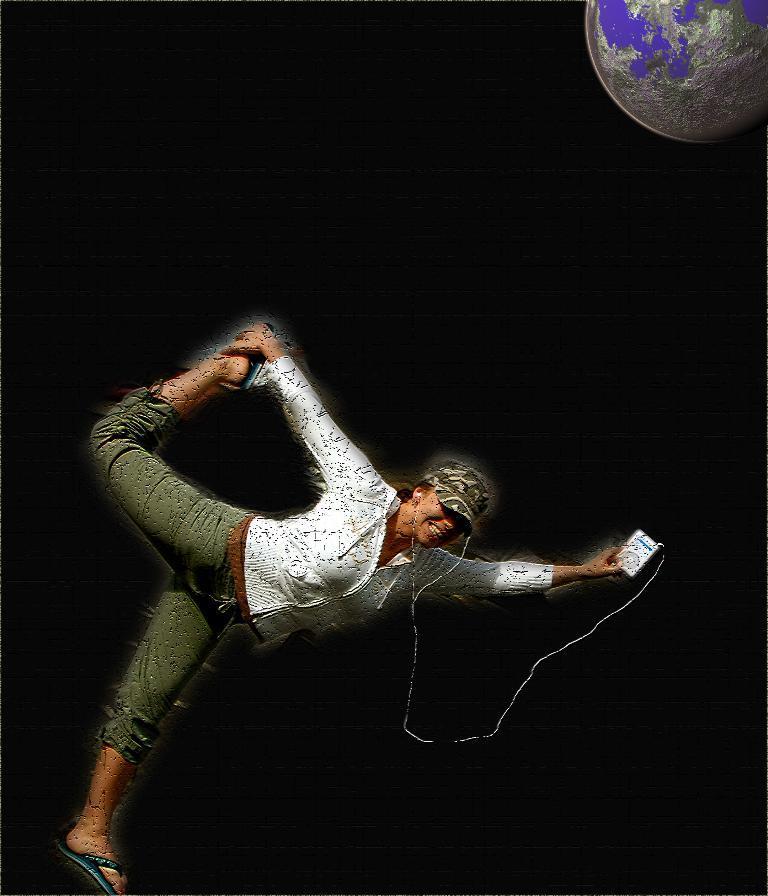In one or two sentences, can you explain what this image depicts? This is an edited image. We can see a person with headphones is holding some object. We can also see the dark background. We can see the globe on the top right corner. 